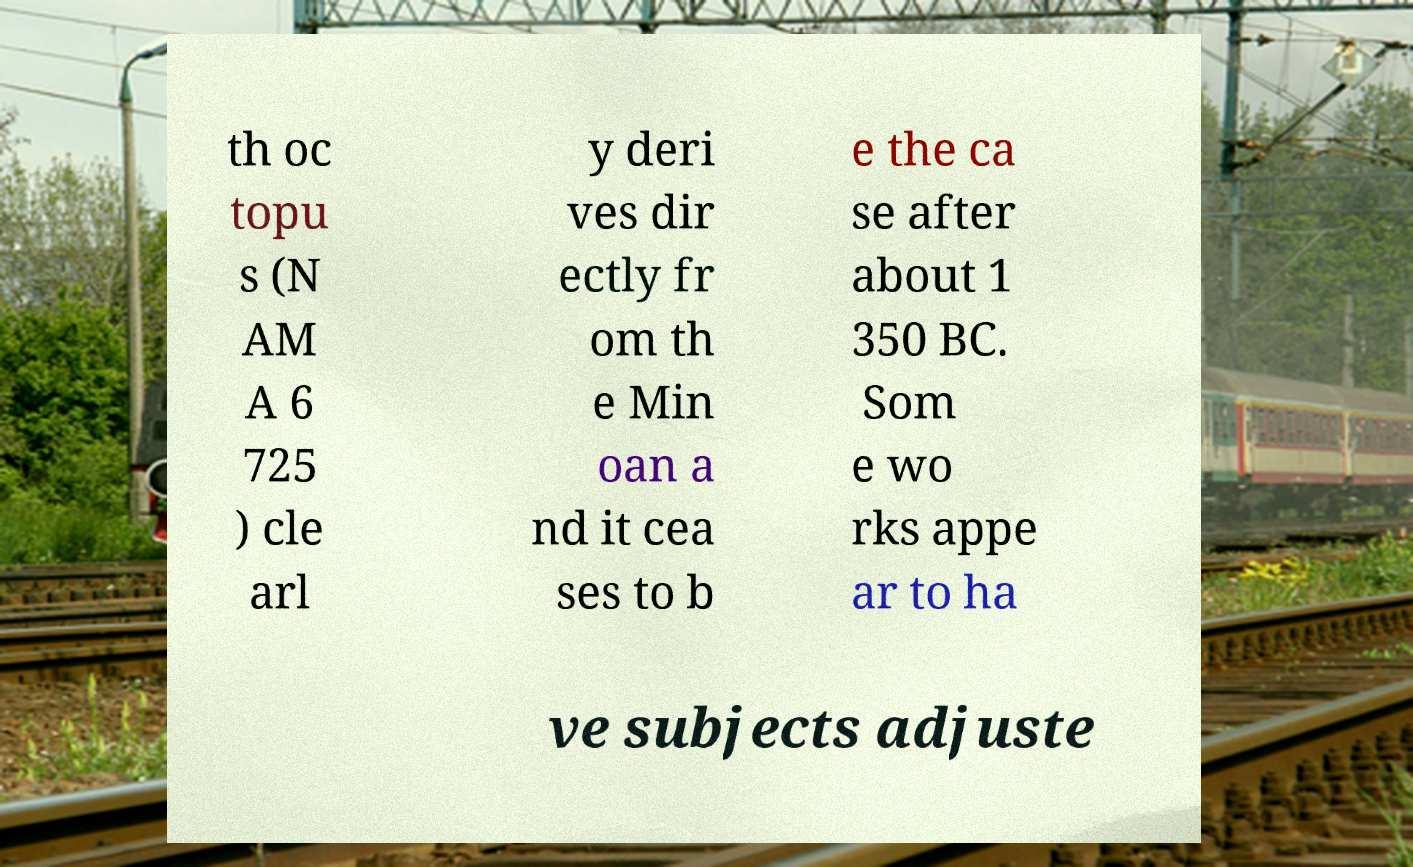There's text embedded in this image that I need extracted. Can you transcribe it verbatim? th oc topu s (N AM A 6 725 ) cle arl y deri ves dir ectly fr om th e Min oan a nd it cea ses to b e the ca se after about 1 350 BC. Som e wo rks appe ar to ha ve subjects adjuste 